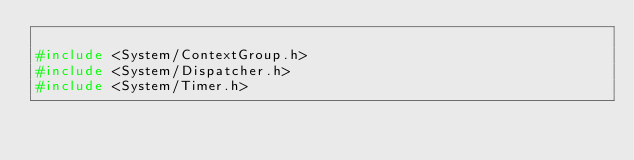<code> <loc_0><loc_0><loc_500><loc_500><_C_>
#include <System/ContextGroup.h>
#include <System/Dispatcher.h>
#include <System/Timer.h>
</code> 